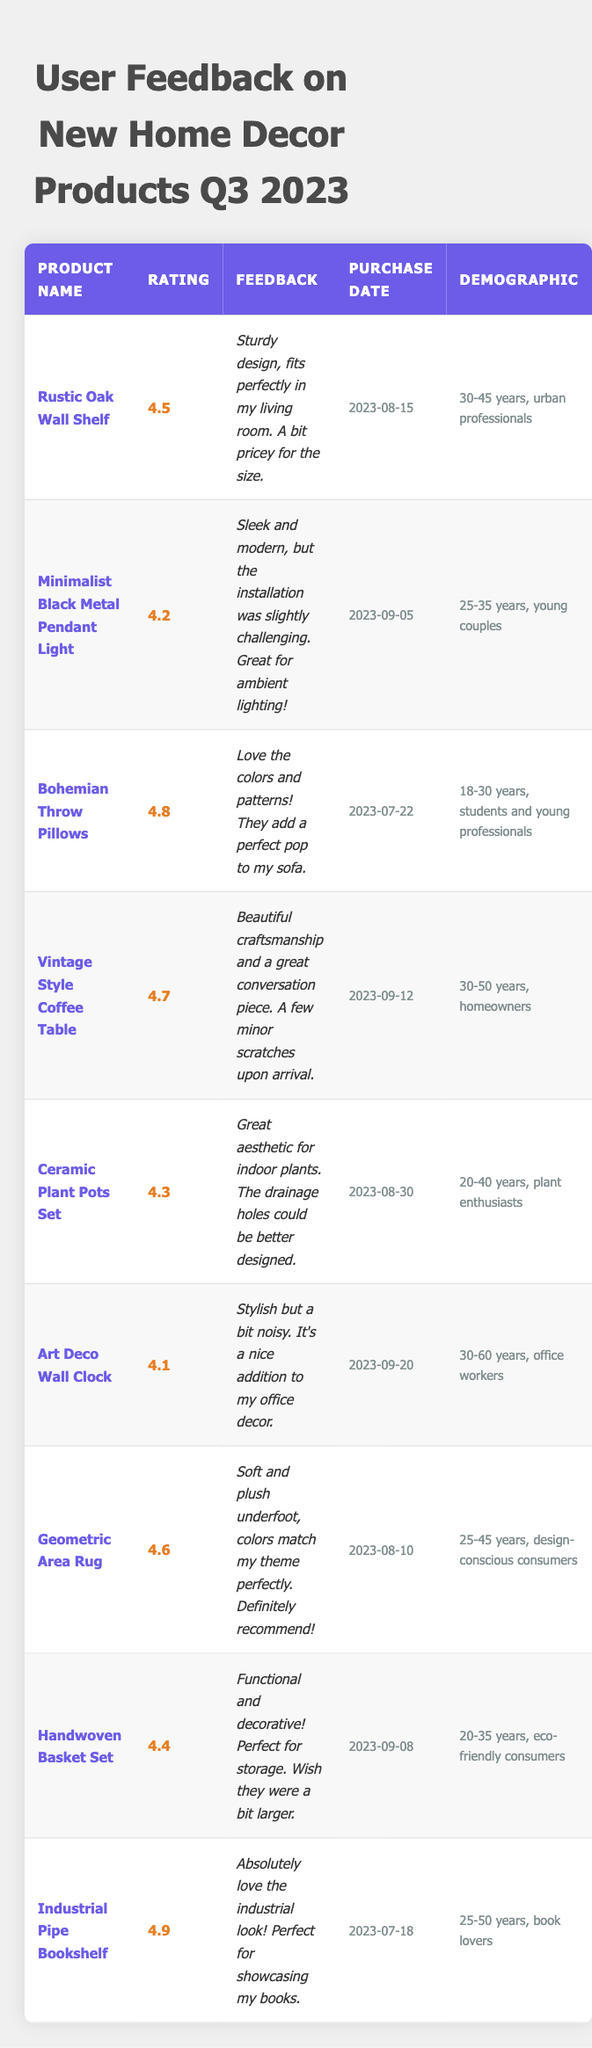What is the highest user rating recorded in the table? The maximum user rating amongst the products listed is 4.9, which corresponds to the "Industrial Pipe Bookshelf."
Answer: 4.9 Which product received the lowest user rating? The product with the lowest user rating is the "Art Deco Wall Clock," which has a rating of 4.1.
Answer: Art Deco Wall Clock What feedback did users provide for the "Vintage Style Coffee Table"? The feedback for the "Vintage Style Coffee Table" is that it has beautiful craftsmanship and is a great conversation piece, but it had a few minor scratches upon arrival.
Answer: Beautiful craftsmanship, minor scratches How many products received a rating of 4.5 or higher? There are six products with ratings of 4.5 or higher: Rustic Oak Wall Shelf, Bohemian Throw Pillows, Vintage Style Coffee Table, Geometric Area Rug, Industrial Pipe Bookshelf, and Minimalist Black Metal Pendant Light.
Answer: 6 Was the "Geometric Area Rug" feedback positive or negative? The feedback for the "Geometric Area Rug" was positive, highlighting that it is soft, plush, and matches the user's theme perfectly.
Answer: Positive Which demographic showed a preference for the "Minimalist Black Metal Pendant Light"? The demographic for "Minimalist Black Metal Pendant Light" is young couples aged 25-35 years.
Answer: Young couples, 25-35 years What is the average user rating of all products listed? To find the average rating, add all the ratings: (4.5 + 4.2 + 4.8 + 4.7 + 4.3 + 4.1 + 4.6 + 4.4 + 4.9) = 42.5 then divide by the number of products (9) gives an average of 4.72.
Answer: 4.72 Are there any products aimed at eco-friendly consumers? Yes, the "Handwoven Basket Set" is aimed at eco-friendly consumers aged 20-35 years.
Answer: Yes What feedback was given for the "Ceramic Plant Pots Set"? The feedback for the "Ceramic Plant Pots Set" stated that it has a great aesthetic for indoor plants, but the drainage holes could be improved.
Answer: Great aesthetic, needs better drainage holes Which product had the earliest purchase date? The "Industrial Pipe Bookshelf" was purchased on 2023-07-18, making it the earliest among the products listed.
Answer: Industrial Pipe Bookshelf 